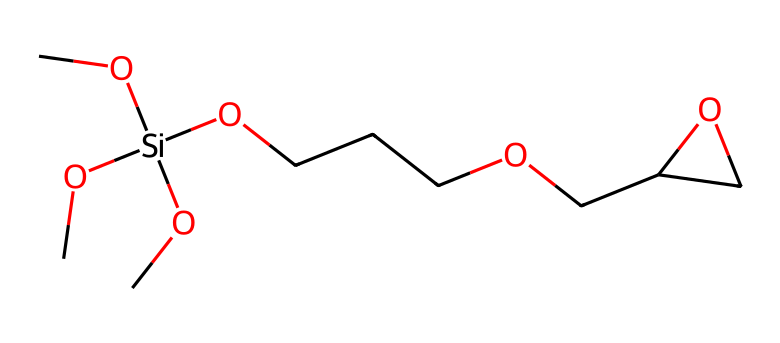What is the total number of carbon atoms in the structure? By analyzing the SMILES representation, we identify all the carbon (C) symbols present. In this case, there are five carbon atoms indicated by the 'C' symbols before the silicon (Si) and along the remaining structure.
Answer: 5 How many silicon atoms are present in this molecule? In the given SMILES representation, there's one instance of the 'Si' symbol, indicating a single silicon atom in the structure.
Answer: 1 What type of functional groups are present in this compound? The structure contains alkoxy groups (as seen with the -O- and -C groups connected to silicon) and it features a carbon chain connected to a cyclic ether (the 1,3-dioxole ring). These functional groups contribute to its adhesive properties.
Answer: alkoxy and cyclic ether What is the likely application of this chemical in electronics? Given the composition and the presence of silane groups, this compound is typically used as an adhesive for bonding electronic components due to its ability to form strong interfaces with substrates.
Answer: adhesive How does the structure of this silane compound enhance adhesion in electronic assemblies? The presence of silicon in the structure allows for strong covalent bonding with the surfaces of electronic components, while the alkoxy groups enhance moisture resistance and compatibility with various materials, thus improving adhesion.
Answer: strong bonding What type of bonding occurs between the silicon and oxygen atoms in this compound? In this compound, the silicon atoms form covalent bonds with oxygen atoms, as indicated by the connection shown in the SMILES representation. Covalent bonding is characterized by the sharing of electrons between these atoms.
Answer: covalent What is the significance of the cyclic structure in this molecule? The cyclic structure (the dioxole ring) enhances the robustness and stability of the adhesive under varying temperature and humidity conditions, which is crucial for electronic applications where environmental factors can affect performance.
Answer: stability 